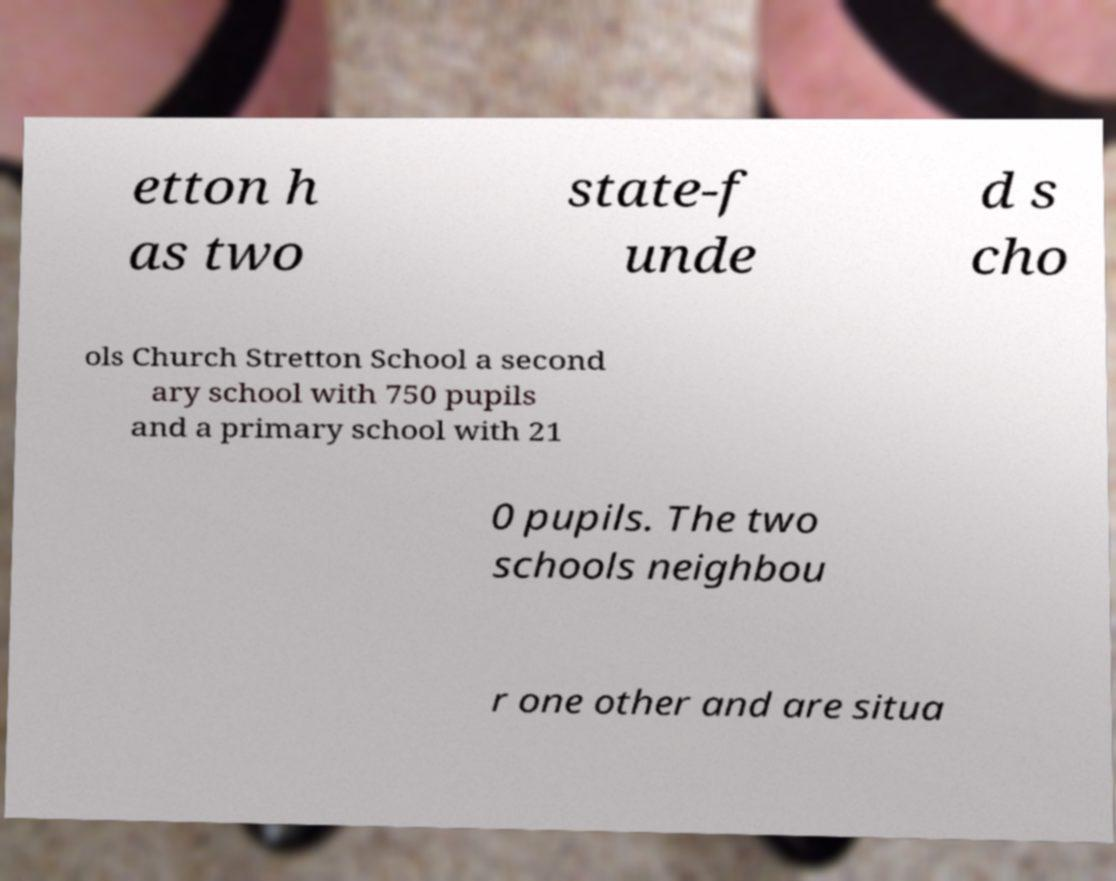For documentation purposes, I need the text within this image transcribed. Could you provide that? etton h as two state-f unde d s cho ols Church Stretton School a second ary school with 750 pupils and a primary school with 21 0 pupils. The two schools neighbou r one other and are situa 